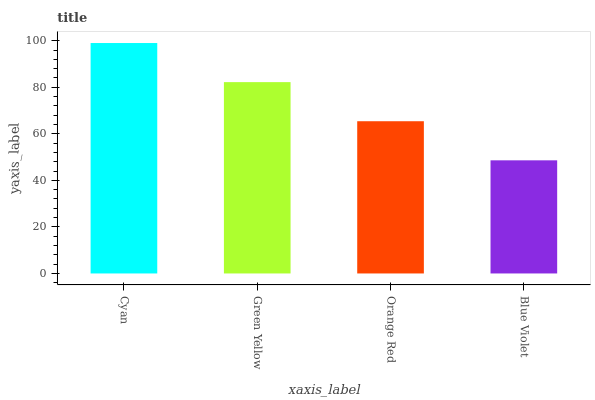Is Blue Violet the minimum?
Answer yes or no. Yes. Is Cyan the maximum?
Answer yes or no. Yes. Is Green Yellow the minimum?
Answer yes or no. No. Is Green Yellow the maximum?
Answer yes or no. No. Is Cyan greater than Green Yellow?
Answer yes or no. Yes. Is Green Yellow less than Cyan?
Answer yes or no. Yes. Is Green Yellow greater than Cyan?
Answer yes or no. No. Is Cyan less than Green Yellow?
Answer yes or no. No. Is Green Yellow the high median?
Answer yes or no. Yes. Is Orange Red the low median?
Answer yes or no. Yes. Is Cyan the high median?
Answer yes or no. No. Is Cyan the low median?
Answer yes or no. No. 